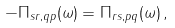Convert formula to latex. <formula><loc_0><loc_0><loc_500><loc_500>- \Pi _ { s r , q p } ( \omega ) = \Pi _ { r s , p q } ( \omega ) \, ,</formula> 